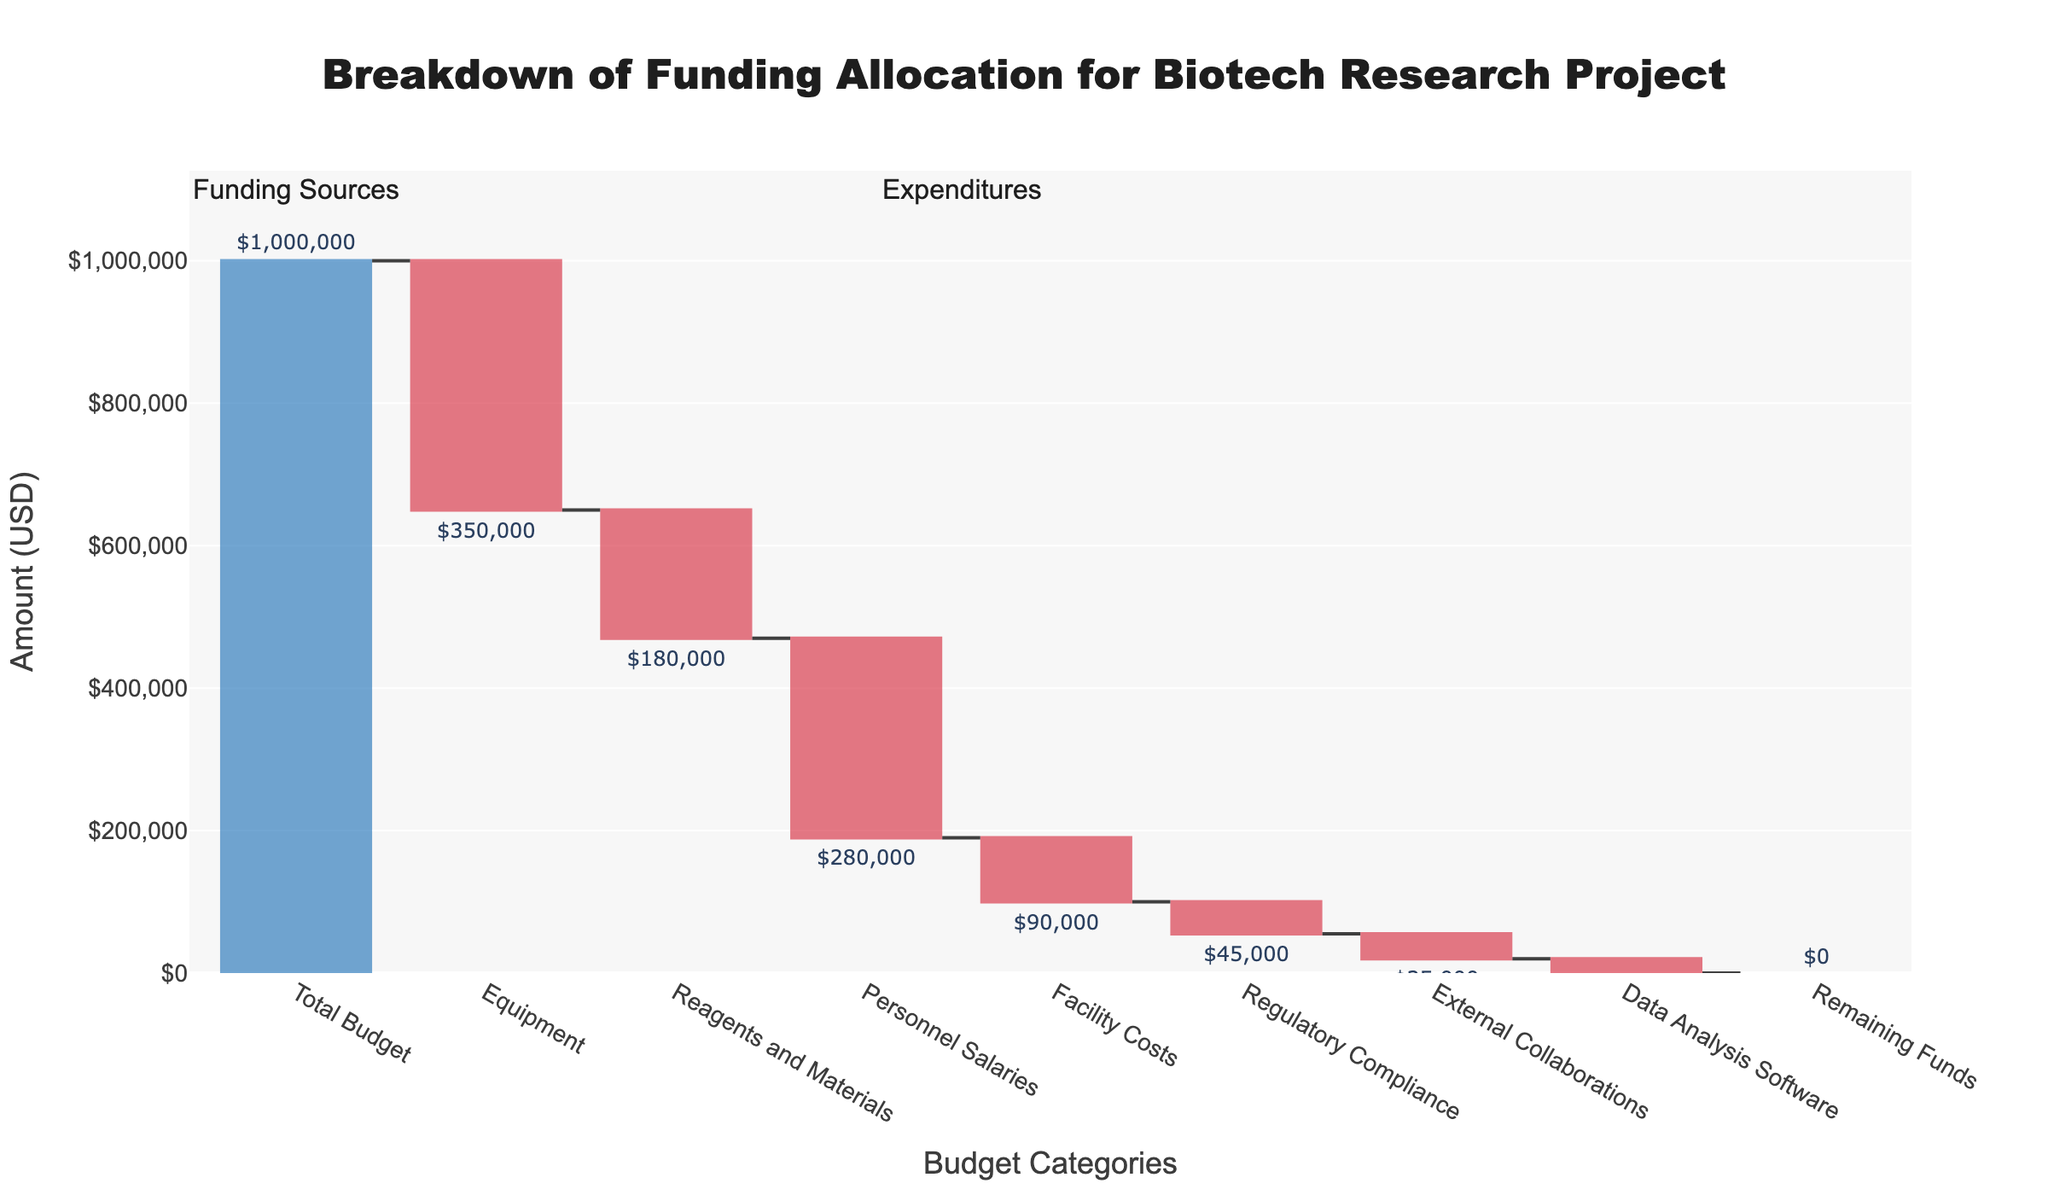What is the total budget allocated for the biotech research project? The total budget is indicated as the first category in the waterfall chart. It's stated as "Total Budget" with a value of $1,000,000.
Answer: $1,000,000 How much is allocated for Equipment? Look at the section labeled "Equipment" in the waterfall chart, which displays a value of -$350,000.
Answer: $350,000 Which category has the smallest allocation? Among the categories, "Data Analysis Software" has the smallest allocation, shown as -$20,000.
Answer: Data Analysis Software What are the total expenditures excluding Equipment and Personnel Salaries? The total expenditure excluding Equipment and Personnel Salaries is obtained by summing the values of Reagents and Materials (-$180,000), Facility Costs (-$90,000), Regulatory Compliance (-$45,000), External Collaborations (-$35,000), and Data Analysis Software (-$20,000). Thus, the total is -$180,000 + (-$90,000) + (-$45,000) + (-$35,000) + (-$20,000) = -$370,000.
Answer: $370,000 How much more is spent on Personnel Salaries compared to Facility Costs? The expenditure for Personnel Salaries is -$280,000 and for Facility Costs, it is -$90,000. The difference is -$280,000 - (-$90,000) = -$190,000.
Answer: $190,000 Which single category, Equipment or Personnel Salaries, accounts for the largest expenditure? Compare the values for Equipment (-$350,000) and Personnel Salaries (-$280,000). Equipment has the larger expenditure.
Answer: Equipment How does the spending on Regulatory Compliance compare to spending on External Collaborations and Data Analysis Software combined? Add the values of External Collaborations (-$35,000) and Data Analysis Software (-$20,000), which equals -$55,000. Compare this to Regulatory Compliance (-$45,000). Since -$45,000 < -$55,000, spending on Regulatory Compliance is less than the combined spending on External Collaborations and Data Analysis Software.
Answer: Less What is the remaining funds after all allocations are deducted from the total budget? According to the waterfall chart, the "Remaining Funds" category value is $0, indicating all funds are allocated.
Answer: $0 What is the total amount spent on non-personnel costs (all costs excluding Personnel Salaries)? Calculate by summing all costs except Personnel Salaries: Equipment (-$350,000), Reagents and Materials (-$180,000), Facility Costs (-$90,000), Regulatory Compliance (-$45,000), External Collaborations (-$35,000), and Data Analysis Software (-$20,000). The total is -$350,000 + (-$180,000) + (-$90,000) + (-$45,000) + (-$35,000) + (-$20,000) = -$720,000.
Answer: $720,000 